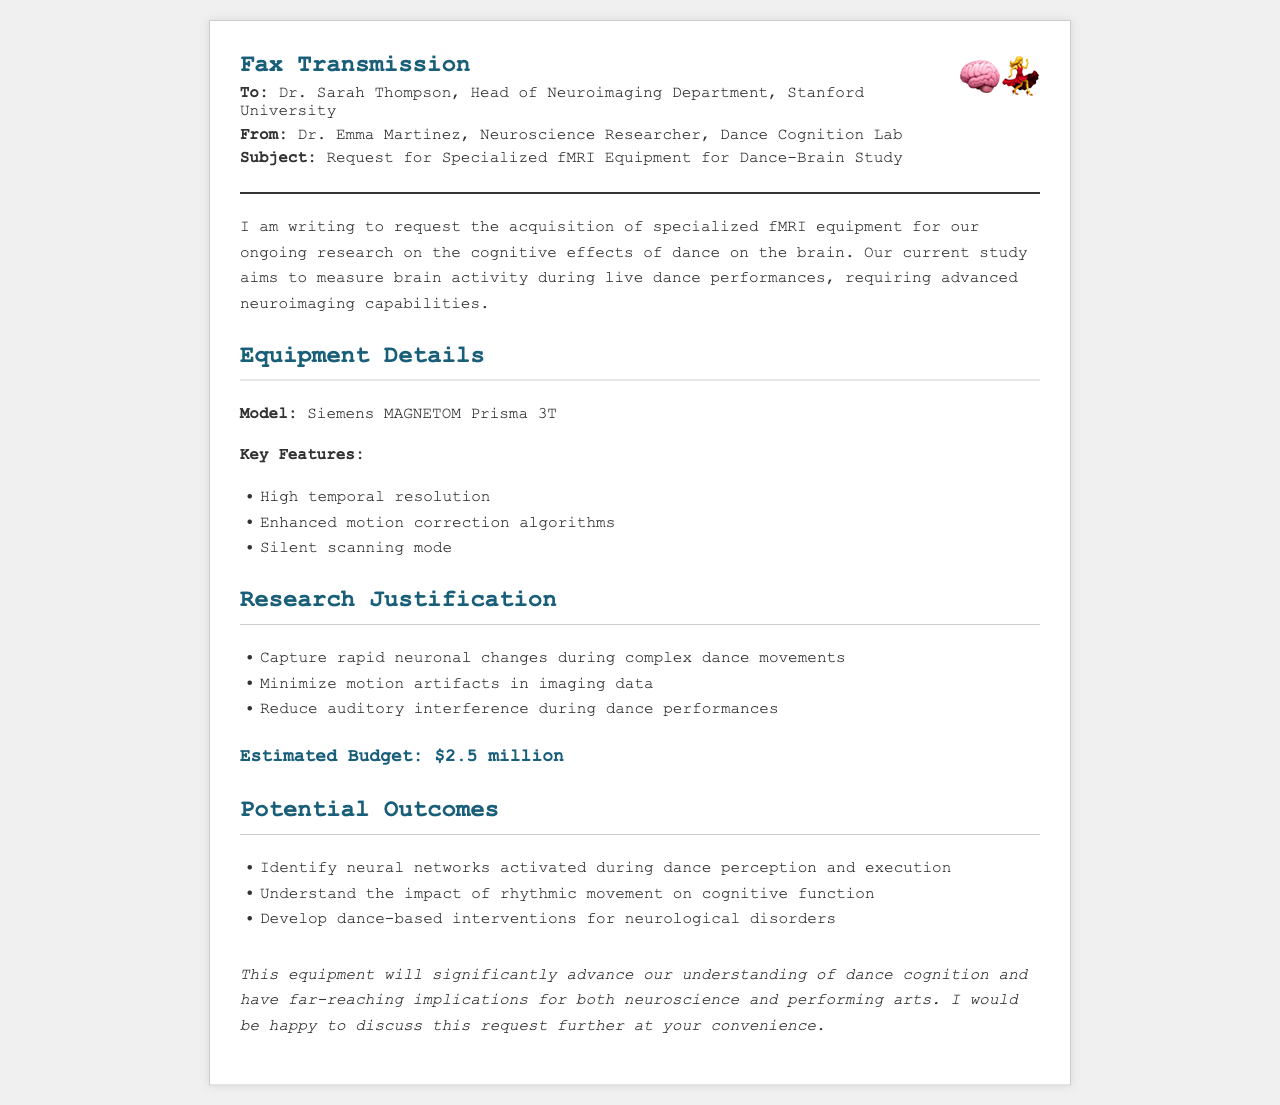What is the model of the requested fMRI equipment? The model of the requested fMRI equipment is specified in the document as "Siemens MAGNETOM Prisma 3T."
Answer: Siemens MAGNETOM Prisma 3T Who is the recipient of the fax? The recipient of the fax is mentioned in the header section as "Dr. Sarah Thompson, Head of Neuroimaging Department, Stanford University."
Answer: Dr. Sarah Thompson What is the estimated budget for the equipment? The estimated budget for the equipment is clearly stated in the document as "$2.5 million."
Answer: $2.5 million What are the key features of the requested fMRI equipment? The key features include high temporal resolution, enhanced motion correction algorithms, and silent scanning mode, all listed under Equipment Details.
Answer: High temporal resolution, enhanced motion correction algorithms, silent scanning mode Which area of research is being focused on in this study? The area of research is focused on studying the "cognitive effects of dance on the brain," as mentioned in the introductory paragraph.
Answer: Cognitive effects of dance on the brain What potential outcome involves neurological disorders? The potential outcome stated in the document is "develop dance-based interventions for neurological disorders," which relates to creating interventions.
Answer: Develop dance-based interventions for neurological disorders What is the purpose of silent scanning mode in the requested equipment? The purpose of silent scanning mode is to "reduce auditory interference during dance performances," as indicated in the justification.
Answer: Reduce auditory interference during dance performances 